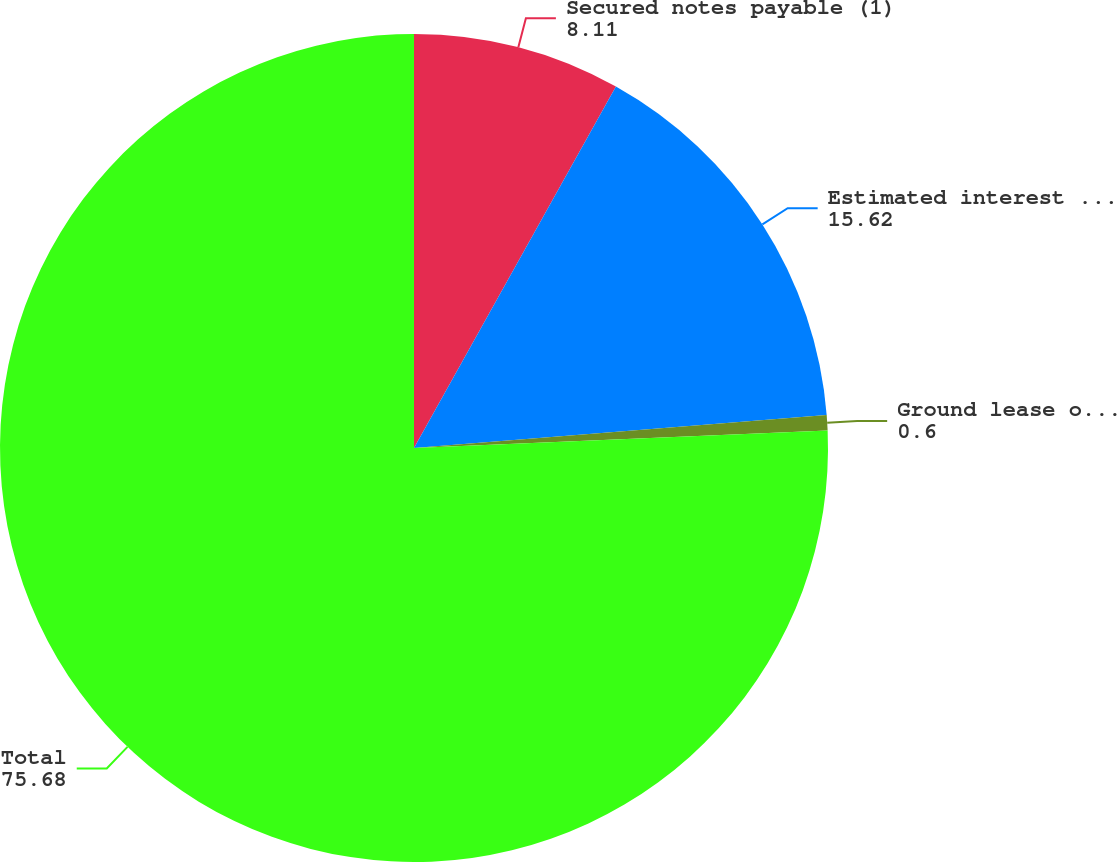Convert chart to OTSL. <chart><loc_0><loc_0><loc_500><loc_500><pie_chart><fcel>Secured notes payable (1)<fcel>Estimated interest payments<fcel>Ground lease obligations<fcel>Total<nl><fcel>8.11%<fcel>15.62%<fcel>0.6%<fcel>75.68%<nl></chart> 